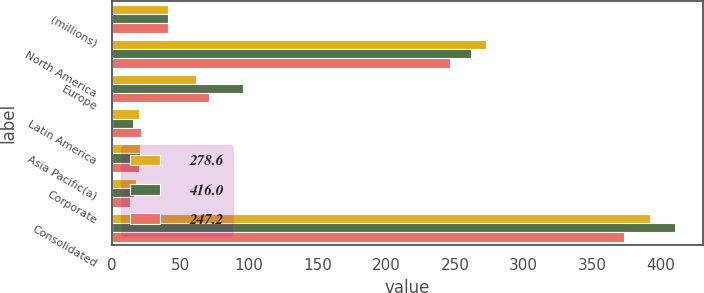Convert chart to OTSL. <chart><loc_0><loc_0><loc_500><loc_500><stacked_bar_chart><ecel><fcel>(millions)<fcel>North America<fcel>Europe<fcel>Latin America<fcel>Asia Pacific(a)<fcel>Corporate<fcel>Consolidated<nl><fcel>278.6<fcel>41.4<fcel>272.3<fcel>61.2<fcel>20<fcel>20.9<fcel>17.4<fcel>391.8<nl><fcel>416<fcel>41.4<fcel>261.4<fcel>95.7<fcel>15.4<fcel>20.9<fcel>16.6<fcel>410<nl><fcel>247.2<fcel>41.4<fcel>246.4<fcel>71.1<fcel>21.6<fcel>20<fcel>13.7<fcel>372.8<nl></chart> 